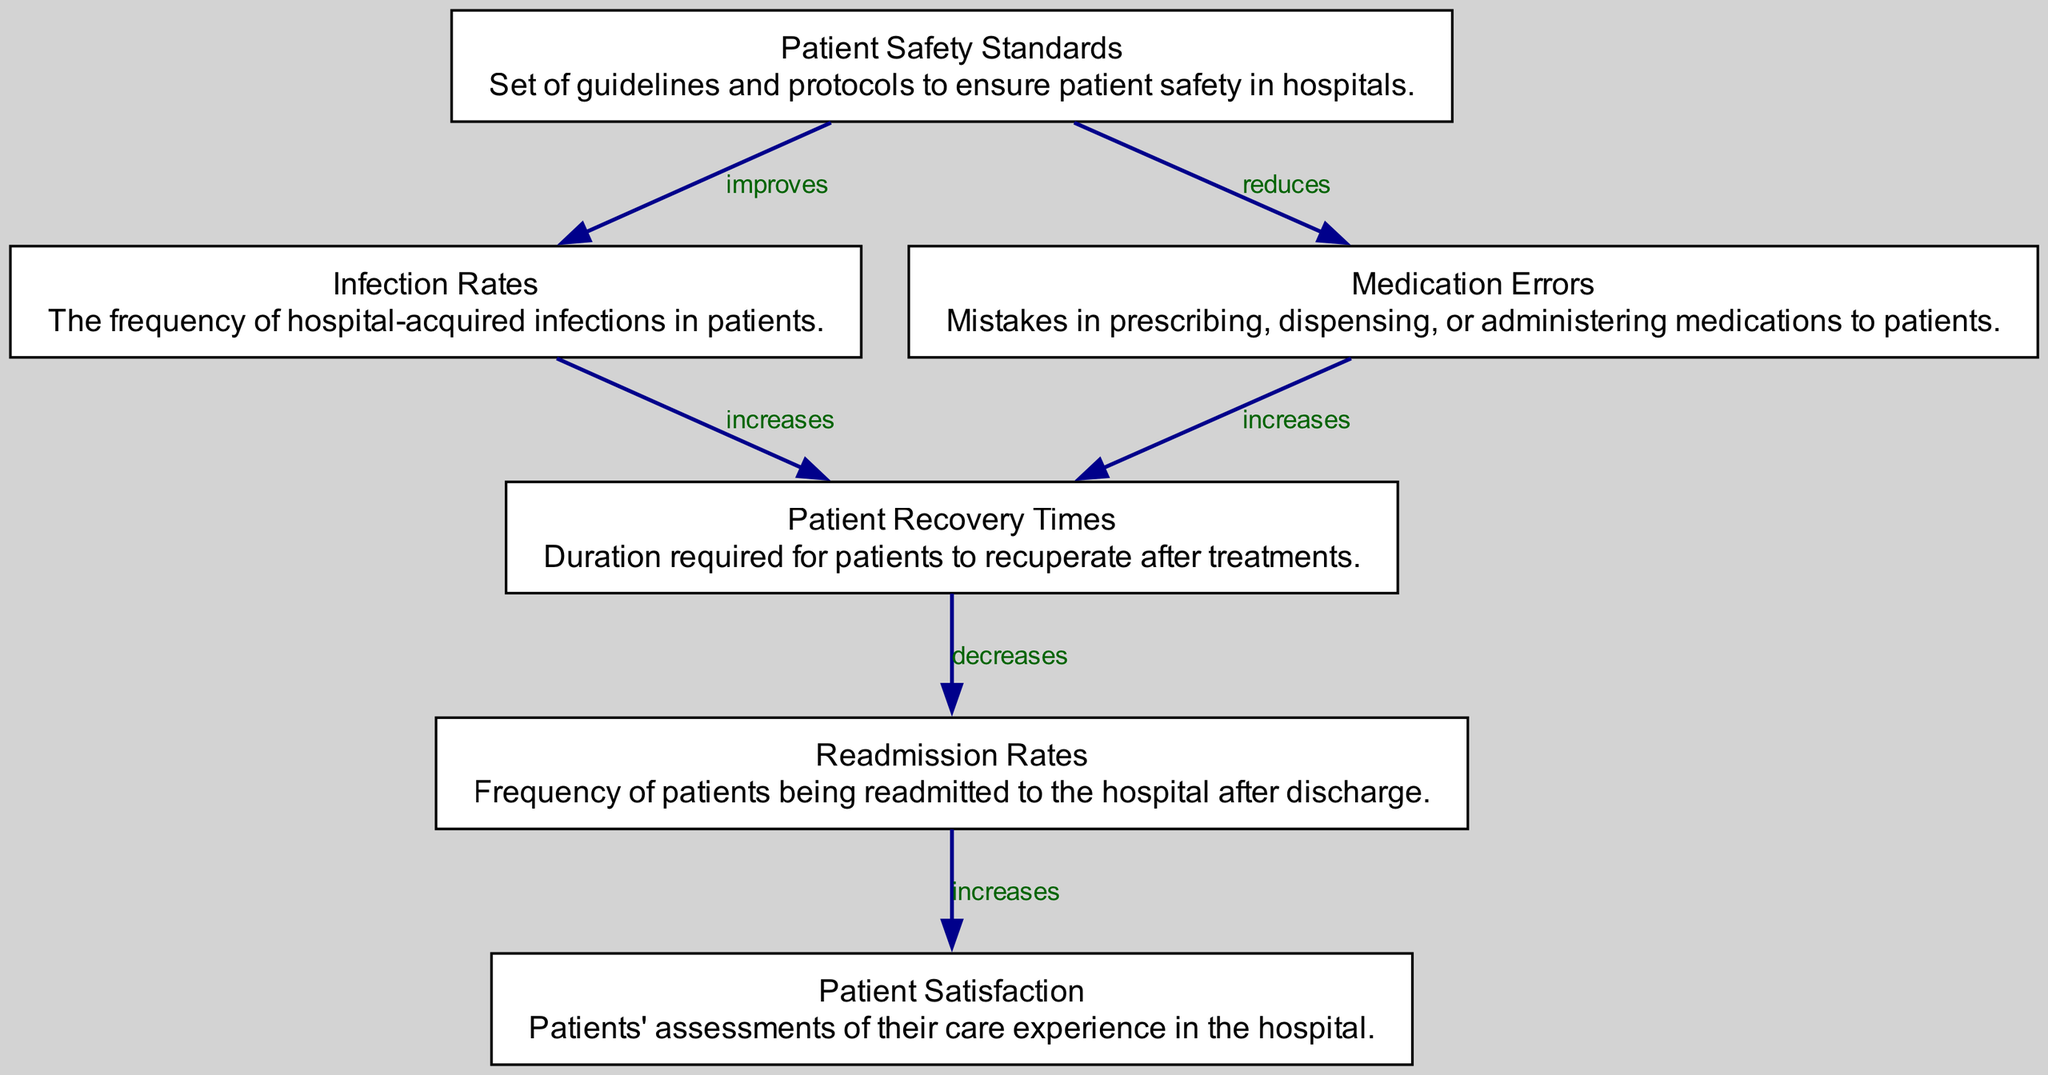What are the two effects of Patient Safety Standards? The diagram shows two relationships stemming from the "Patient Safety Standards" node: it leads to "Infection Rates" with the relationship "improves," and to "Medication Errors" with the relationship "reduces." Thus, the two effects are improving infection rates and reducing medication errors.
Answer: improves, reduces How does Infection Rates affect Patient Recovery Times? The diagram indicates a directed edge from "Infection Rates" to "Patient Recovery Times," and the relationship is described as "increases." This means that higher infection rates lead to longer patient recovery times.
Answer: increases What is the impact of Patient Recovery Times on Readmission Rates? The relation from "Patient Recovery Times" to "Readmission Rates" shows that it has a direct impact described as "decreases." This indicates that as recovery times increase, the rates at which patients are readmitted decrease.
Answer: decreases What is the overall relationship between Readmission Rates and Patient Satisfaction? The diagram presents a directed edge going from "Readmission Rates" to "Patient Satisfaction" with the relationship labeled as "increases." This means that when readmission rates decrease, patient satisfaction improves.
Answer: increases How many total nodes are present in the diagram? The diagram contains six nodes: Patient Safety Standards, Infection Rates, Medication Errors, Patient Recovery Times, Readmission Rates, and Patient Satisfaction. Counting all these gives a total of six nodes.
Answer: 6 What is the connection between Medication Errors and Patient Recovery Times? The diagram shows that "Medication Errors" impacts "Patient Recovery Times" through a directed edge marked as "increases." Therefore, this indicates that medication errors lead to an increase in the time required for patient recovery.
Answer: increases Which node has the most outgoing edges? After analyzing the diagram, "Patient Safety Standards" has two outgoing edges: one to "Infection Rates" (improves) and one to "Medication Errors" (reduces). No other node has more than one outgoing edge. Thus, it has the most outgoing edges.
Answer: Patient Safety Standards What is the relationship between Patient Safety Standards and both Infection Rates and Medication Errors? From the diagram, "Patient Safety Standards" has a positive influence on both these variables. It improves infection rates and reduces medication errors, showcasing its critical role in hospital safety standards.
Answer: improves and reduces 